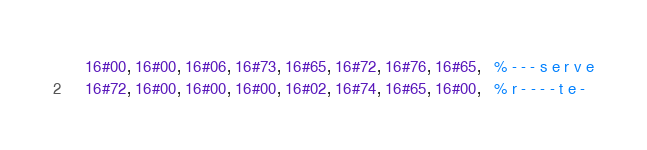<code> <loc_0><loc_0><loc_500><loc_500><_Erlang_>    16#00, 16#00, 16#06, 16#73, 16#65, 16#72, 16#76, 16#65,   % - - - s e r v e
    16#72, 16#00, 16#00, 16#00, 16#02, 16#74, 16#65, 16#00,   % r - - - - t e -</code> 